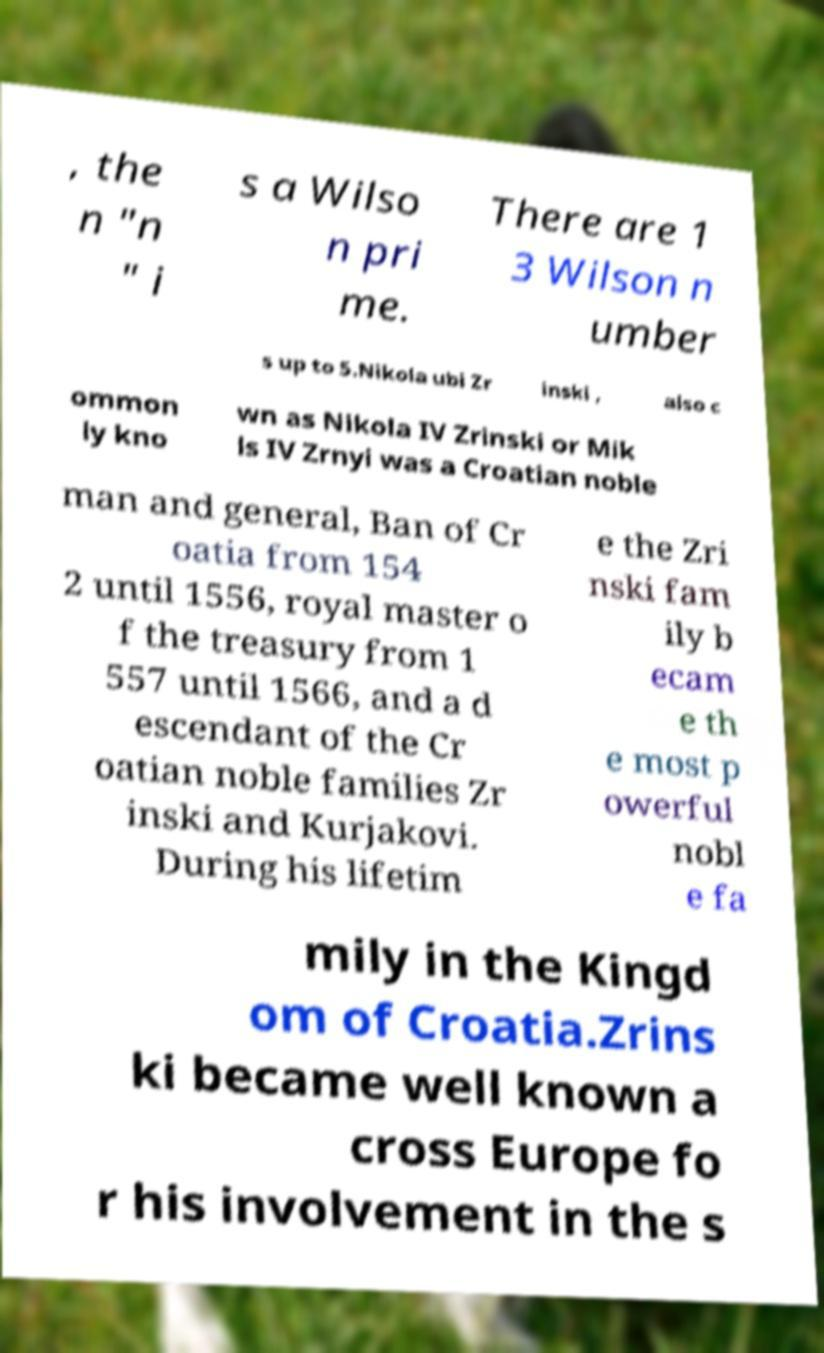Please identify and transcribe the text found in this image. , the n "n " i s a Wilso n pri me. There are 1 3 Wilson n umber s up to 5.Nikola ubi Zr inski , also c ommon ly kno wn as Nikola IV Zrinski or Mik ls IV Zrnyi was a Croatian noble man and general, Ban of Cr oatia from 154 2 until 1556, royal master o f the treasury from 1 557 until 1566, and a d escendant of the Cr oatian noble families Zr inski and Kurjakovi. During his lifetim e the Zri nski fam ily b ecam e th e most p owerful nobl e fa mily in the Kingd om of Croatia.Zrins ki became well known a cross Europe fo r his involvement in the s 